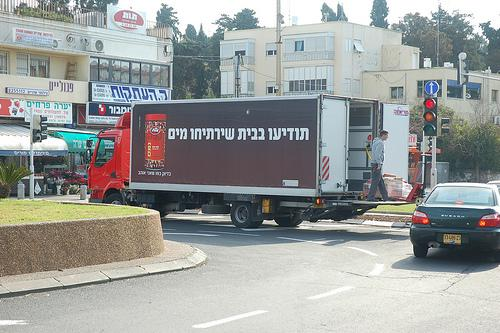How many traffic lights are visible in the image, and what object are they connected to? There is one black traffic light visible, connected to a pole. What objects can be seen in the distance behind the tall buildings? Trees can be seen in the distance behind the tall buildings. Describe the surface where the red truck and car are parked. Both the red truck and the car are parked on a cement road with white lines painted on it. Briefly describe the scene shown in the image. The image shows a city street scene with a red truck, a dark green car, a man standing by the truck, traffic light, and some buildings in the background. Examine the objects on the road, and describe any shadows present. There is a shadow on the cement road, possibly cast by the parked vehicles or other objects nearby. What type of object are the two headlights part of? The two headlights are part of a car. What is the activity of the man in the image, and where is his position related to the truck? The man is standing behind a truck near the back of it. In the image, what is the status of the truck and mention any visible writing on it. The truck is parked on the street, and there is writing on the side of it. Identify the type and color of the vehicle parked on the cement road. The vehicle is a dark green car. What is the appearance of the building in the background, and any signs present on the building? The building in the background is beige-colored, and there are signs visible on it. 